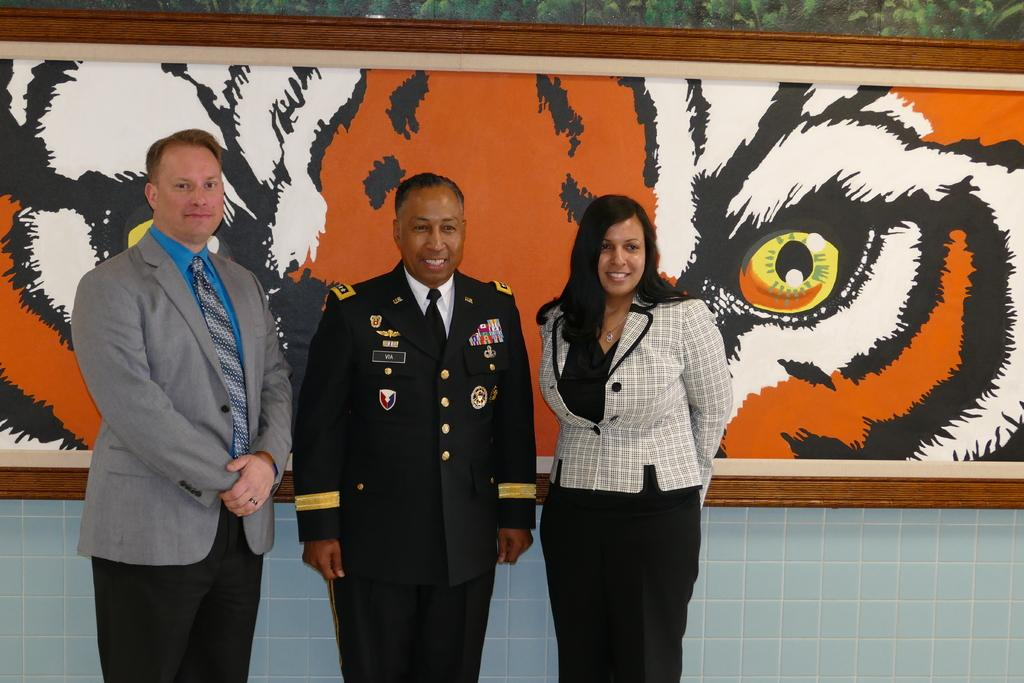What is the main subject of the image? The main subject of the image is people standing in the middle of the image. Can you describe the background of the image? There is a frame visible in the background of the image. What type of prose is being recited by the people in the image? There is no indication in the image that the people are reciting any prose. How does the addition of the frame in the background affect the overall composition of the image? The provided facts do not include any information about the composition of the image or the effect of the frame on it. 